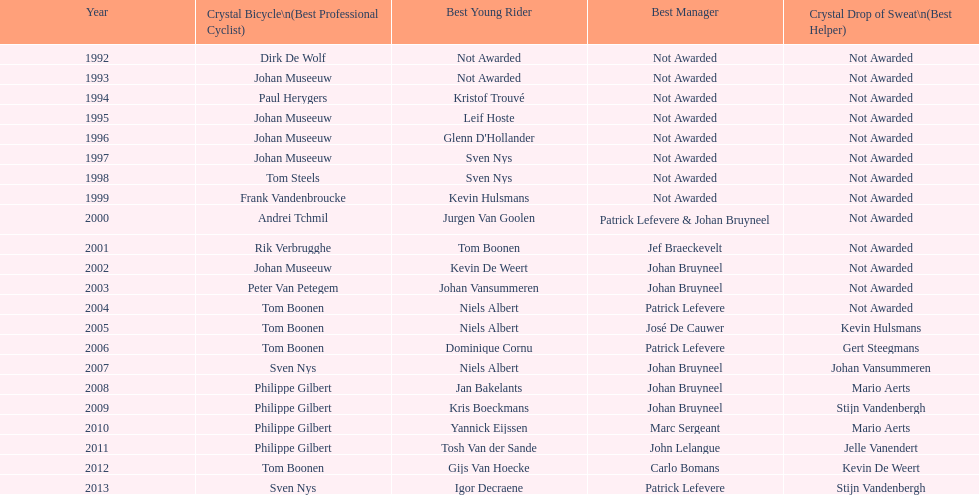Count the occurrences of johan bryneel's name in all the given lists. 6. 